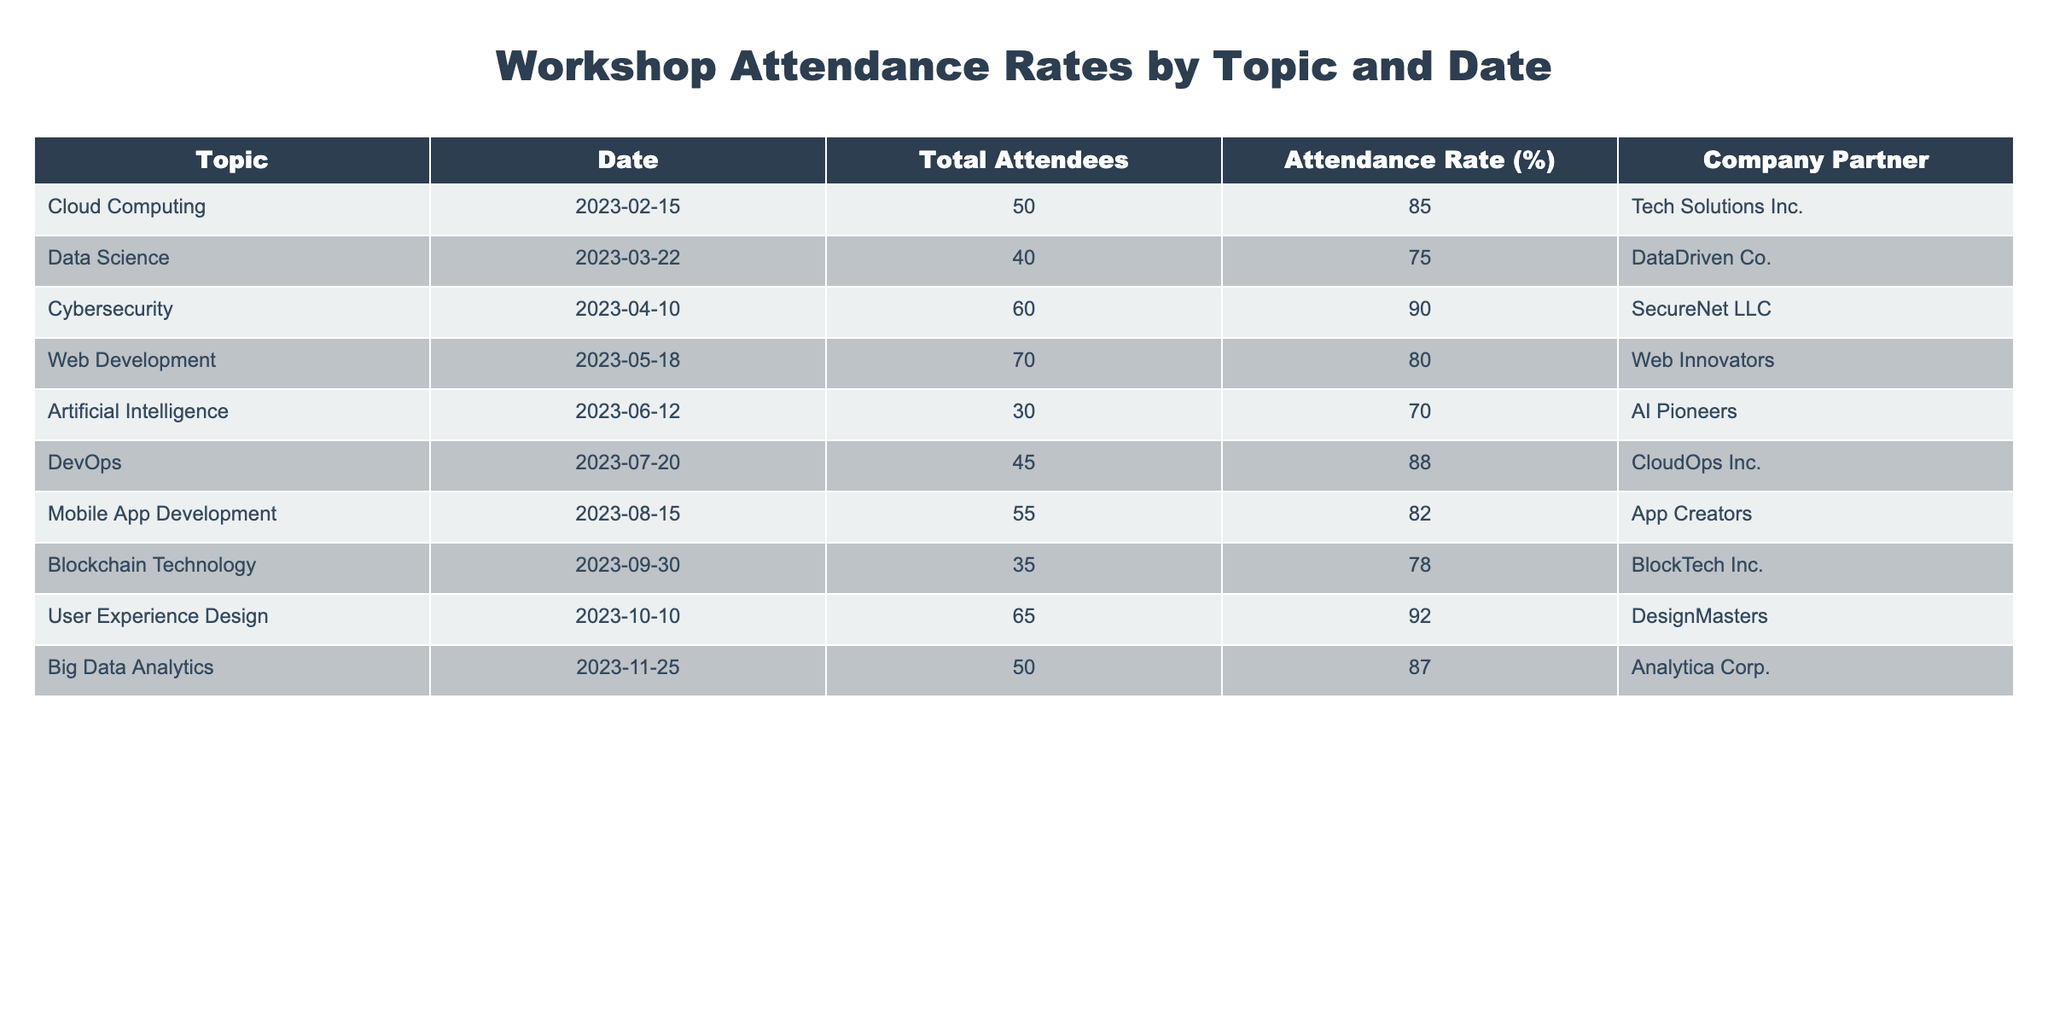What is the attendance rate for Cybersecurity workshops? The table clearly states that the attendance rate for the Cybersecurity workshop on April 10, 2023, is 90%.
Answer: 90% Which topic had the lowest attendance rate? Looking across the attendance rates, Artificial Intelligence has the lowest rate at 70%.
Answer: Artificial Intelligence What is the average attendance rate across all topics? To find the average, we sum the attendance rates: (85 + 75 + 90 + 80 + 70 + 88 + 82 + 78 + 92 + 87) = 837. There are 10 topics, so the average is 837/10 = 83.7%.
Answer: 83.7% Did any workshop have an attendance rate above 85%? Yes, the workshops on Cybersecurity (90%), DevOps (88%), and User Experience Design (92%) all had attendance rates above 85%.
Answer: Yes What is the total number of attendees for workshops that are related to cloud technologies? Cloud Computing and DevOps are related to cloud technologies. Their total attendees are 50 for Cloud Computing and 45 for DevOps, which sums to 50 + 45 = 95 attendees.
Answer: 95 Is there a correlation between the total number of attendees and the attendance rate? A detailed analysis would be needed, but from visual inspection the tables suggest that higher attendance numbers do not guarantee higher attendance rates, such as with Data Science (40 attendees, 75% rate) vs. Cybersecurity (60 attendees, 90% rate).
Answer: No Which company partner has the highest attendance rate for their workshop? The User Experience Design workshop, partnered with DesignMasters, has the highest attendance rate at 92%.
Answer: DesignMasters How many workshops had more than 60 attendees? The workshops with more than 60 attendees are Cybersecurity (60), Web Development (70), and Mobile App Development (55) resulting in 3 workshops having more than 60 attendees.
Answer: 3 What is the difference in attendance rates between the highest and lowest rates? The highest attendance rate is for User Experience Design at 92%, and the lowest is for Artificial Intelligence at 70%. The difference is 92 - 70 = 22%.
Answer: 22% 